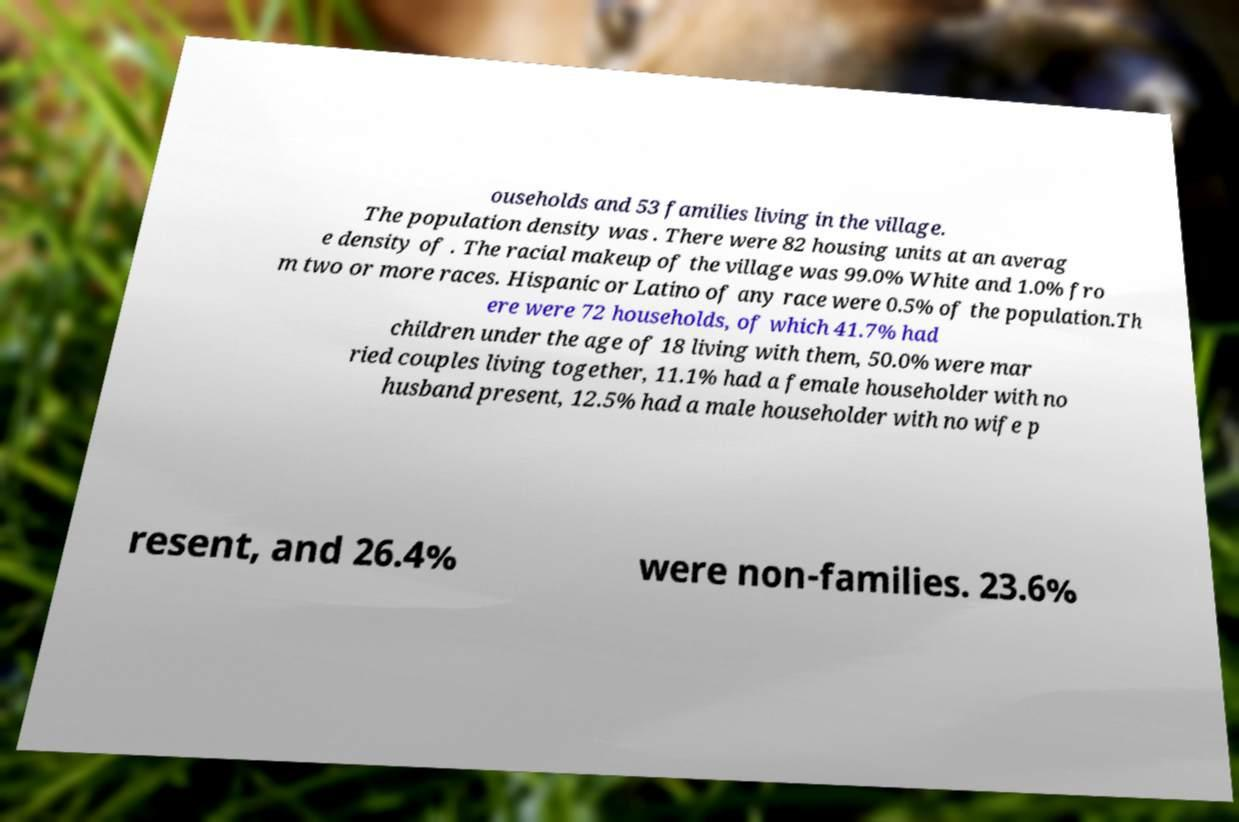Please read and relay the text visible in this image. What does it say? ouseholds and 53 families living in the village. The population density was . There were 82 housing units at an averag e density of . The racial makeup of the village was 99.0% White and 1.0% fro m two or more races. Hispanic or Latino of any race were 0.5% of the population.Th ere were 72 households, of which 41.7% had children under the age of 18 living with them, 50.0% were mar ried couples living together, 11.1% had a female householder with no husband present, 12.5% had a male householder with no wife p resent, and 26.4% were non-families. 23.6% 